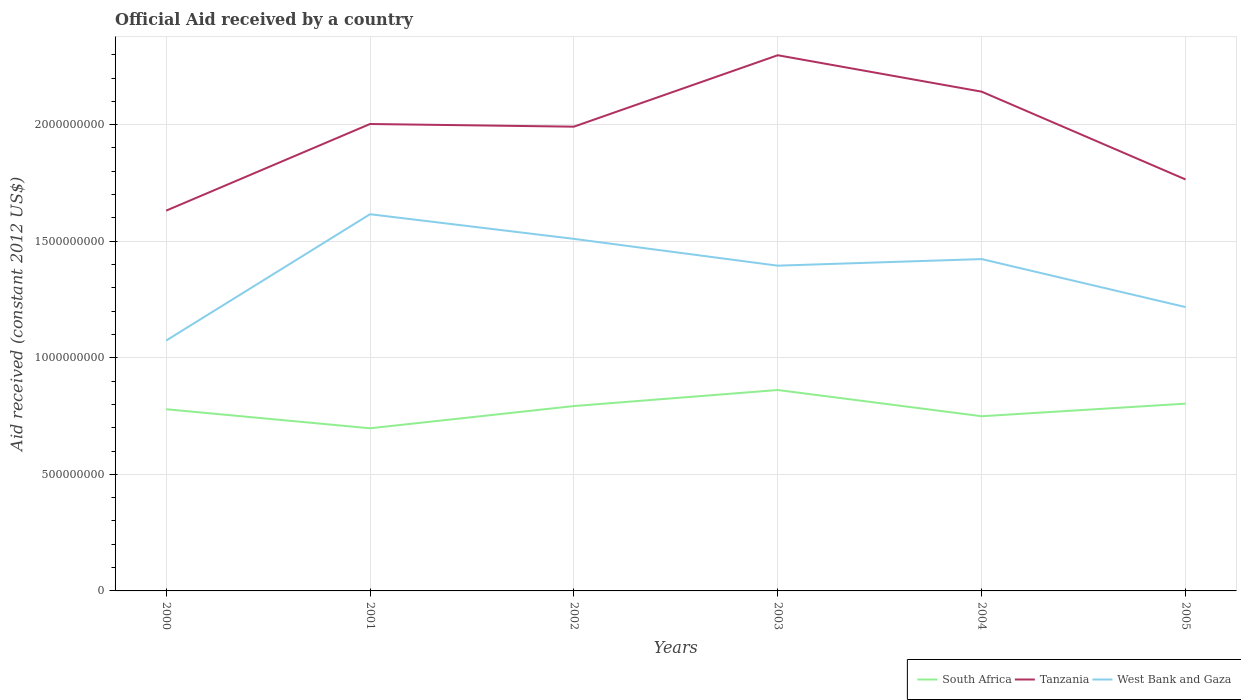How many different coloured lines are there?
Make the answer very short. 3. Does the line corresponding to West Bank and Gaza intersect with the line corresponding to South Africa?
Keep it short and to the point. No. Across all years, what is the maximum net official aid received in South Africa?
Provide a short and direct response. 6.98e+08. What is the total net official aid received in South Africa in the graph?
Ensure brevity in your answer.  -6.88e+07. What is the difference between the highest and the second highest net official aid received in West Bank and Gaza?
Your answer should be compact. 5.42e+08. Is the net official aid received in South Africa strictly greater than the net official aid received in West Bank and Gaza over the years?
Your answer should be compact. Yes. What is the difference between two consecutive major ticks on the Y-axis?
Provide a short and direct response. 5.00e+08. Are the values on the major ticks of Y-axis written in scientific E-notation?
Give a very brief answer. No. How many legend labels are there?
Provide a short and direct response. 3. How are the legend labels stacked?
Ensure brevity in your answer.  Horizontal. What is the title of the graph?
Provide a succinct answer. Official Aid received by a country. What is the label or title of the Y-axis?
Give a very brief answer. Aid received (constant 2012 US$). What is the Aid received (constant 2012 US$) of South Africa in 2000?
Your response must be concise. 7.79e+08. What is the Aid received (constant 2012 US$) in Tanzania in 2000?
Provide a short and direct response. 1.63e+09. What is the Aid received (constant 2012 US$) in West Bank and Gaza in 2000?
Provide a short and direct response. 1.07e+09. What is the Aid received (constant 2012 US$) in South Africa in 2001?
Your answer should be very brief. 6.98e+08. What is the Aid received (constant 2012 US$) in Tanzania in 2001?
Your answer should be compact. 2.00e+09. What is the Aid received (constant 2012 US$) in West Bank and Gaza in 2001?
Provide a succinct answer. 1.62e+09. What is the Aid received (constant 2012 US$) of South Africa in 2002?
Ensure brevity in your answer.  7.93e+08. What is the Aid received (constant 2012 US$) of Tanzania in 2002?
Give a very brief answer. 1.99e+09. What is the Aid received (constant 2012 US$) of West Bank and Gaza in 2002?
Your answer should be compact. 1.51e+09. What is the Aid received (constant 2012 US$) of South Africa in 2003?
Keep it short and to the point. 8.62e+08. What is the Aid received (constant 2012 US$) in Tanzania in 2003?
Your answer should be compact. 2.30e+09. What is the Aid received (constant 2012 US$) of West Bank and Gaza in 2003?
Provide a succinct answer. 1.40e+09. What is the Aid received (constant 2012 US$) of South Africa in 2004?
Make the answer very short. 7.49e+08. What is the Aid received (constant 2012 US$) of Tanzania in 2004?
Offer a terse response. 2.14e+09. What is the Aid received (constant 2012 US$) in West Bank and Gaza in 2004?
Offer a terse response. 1.42e+09. What is the Aid received (constant 2012 US$) in South Africa in 2005?
Your answer should be compact. 8.03e+08. What is the Aid received (constant 2012 US$) of Tanzania in 2005?
Ensure brevity in your answer.  1.77e+09. What is the Aid received (constant 2012 US$) of West Bank and Gaza in 2005?
Your answer should be compact. 1.22e+09. Across all years, what is the maximum Aid received (constant 2012 US$) of South Africa?
Offer a terse response. 8.62e+08. Across all years, what is the maximum Aid received (constant 2012 US$) of Tanzania?
Give a very brief answer. 2.30e+09. Across all years, what is the maximum Aid received (constant 2012 US$) of West Bank and Gaza?
Your response must be concise. 1.62e+09. Across all years, what is the minimum Aid received (constant 2012 US$) in South Africa?
Offer a very short reply. 6.98e+08. Across all years, what is the minimum Aid received (constant 2012 US$) in Tanzania?
Offer a very short reply. 1.63e+09. Across all years, what is the minimum Aid received (constant 2012 US$) of West Bank and Gaza?
Your answer should be compact. 1.07e+09. What is the total Aid received (constant 2012 US$) of South Africa in the graph?
Offer a terse response. 4.68e+09. What is the total Aid received (constant 2012 US$) of Tanzania in the graph?
Provide a succinct answer. 1.18e+1. What is the total Aid received (constant 2012 US$) in West Bank and Gaza in the graph?
Make the answer very short. 8.24e+09. What is the difference between the Aid received (constant 2012 US$) in South Africa in 2000 and that in 2001?
Offer a terse response. 8.16e+07. What is the difference between the Aid received (constant 2012 US$) in Tanzania in 2000 and that in 2001?
Offer a very short reply. -3.72e+08. What is the difference between the Aid received (constant 2012 US$) of West Bank and Gaza in 2000 and that in 2001?
Give a very brief answer. -5.42e+08. What is the difference between the Aid received (constant 2012 US$) in South Africa in 2000 and that in 2002?
Offer a very short reply. -1.37e+07. What is the difference between the Aid received (constant 2012 US$) of Tanzania in 2000 and that in 2002?
Offer a terse response. -3.60e+08. What is the difference between the Aid received (constant 2012 US$) in West Bank and Gaza in 2000 and that in 2002?
Offer a very short reply. -4.36e+08. What is the difference between the Aid received (constant 2012 US$) in South Africa in 2000 and that in 2003?
Keep it short and to the point. -8.25e+07. What is the difference between the Aid received (constant 2012 US$) of Tanzania in 2000 and that in 2003?
Make the answer very short. -6.67e+08. What is the difference between the Aid received (constant 2012 US$) in West Bank and Gaza in 2000 and that in 2003?
Your answer should be very brief. -3.21e+08. What is the difference between the Aid received (constant 2012 US$) of South Africa in 2000 and that in 2004?
Your answer should be compact. 3.00e+07. What is the difference between the Aid received (constant 2012 US$) of Tanzania in 2000 and that in 2004?
Offer a terse response. -5.10e+08. What is the difference between the Aid received (constant 2012 US$) of West Bank and Gaza in 2000 and that in 2004?
Offer a very short reply. -3.50e+08. What is the difference between the Aid received (constant 2012 US$) in South Africa in 2000 and that in 2005?
Your answer should be very brief. -2.40e+07. What is the difference between the Aid received (constant 2012 US$) of Tanzania in 2000 and that in 2005?
Make the answer very short. -1.34e+08. What is the difference between the Aid received (constant 2012 US$) in West Bank and Gaza in 2000 and that in 2005?
Make the answer very short. -1.44e+08. What is the difference between the Aid received (constant 2012 US$) of South Africa in 2001 and that in 2002?
Your answer should be very brief. -9.53e+07. What is the difference between the Aid received (constant 2012 US$) in Tanzania in 2001 and that in 2002?
Your answer should be very brief. 1.14e+07. What is the difference between the Aid received (constant 2012 US$) in West Bank and Gaza in 2001 and that in 2002?
Provide a short and direct response. 1.06e+08. What is the difference between the Aid received (constant 2012 US$) of South Africa in 2001 and that in 2003?
Offer a terse response. -1.64e+08. What is the difference between the Aid received (constant 2012 US$) of Tanzania in 2001 and that in 2003?
Provide a short and direct response. -2.95e+08. What is the difference between the Aid received (constant 2012 US$) of West Bank and Gaza in 2001 and that in 2003?
Provide a succinct answer. 2.21e+08. What is the difference between the Aid received (constant 2012 US$) of South Africa in 2001 and that in 2004?
Ensure brevity in your answer.  -5.17e+07. What is the difference between the Aid received (constant 2012 US$) in Tanzania in 2001 and that in 2004?
Keep it short and to the point. -1.39e+08. What is the difference between the Aid received (constant 2012 US$) in West Bank and Gaza in 2001 and that in 2004?
Offer a terse response. 1.92e+08. What is the difference between the Aid received (constant 2012 US$) of South Africa in 2001 and that in 2005?
Ensure brevity in your answer.  -1.06e+08. What is the difference between the Aid received (constant 2012 US$) in Tanzania in 2001 and that in 2005?
Ensure brevity in your answer.  2.38e+08. What is the difference between the Aid received (constant 2012 US$) in West Bank and Gaza in 2001 and that in 2005?
Provide a succinct answer. 3.98e+08. What is the difference between the Aid received (constant 2012 US$) in South Africa in 2002 and that in 2003?
Offer a terse response. -6.88e+07. What is the difference between the Aid received (constant 2012 US$) in Tanzania in 2002 and that in 2003?
Provide a succinct answer. -3.06e+08. What is the difference between the Aid received (constant 2012 US$) in West Bank and Gaza in 2002 and that in 2003?
Your response must be concise. 1.15e+08. What is the difference between the Aid received (constant 2012 US$) of South Africa in 2002 and that in 2004?
Your answer should be compact. 4.37e+07. What is the difference between the Aid received (constant 2012 US$) of Tanzania in 2002 and that in 2004?
Your answer should be compact. -1.50e+08. What is the difference between the Aid received (constant 2012 US$) in West Bank and Gaza in 2002 and that in 2004?
Ensure brevity in your answer.  8.66e+07. What is the difference between the Aid received (constant 2012 US$) of South Africa in 2002 and that in 2005?
Your answer should be compact. -1.03e+07. What is the difference between the Aid received (constant 2012 US$) of Tanzania in 2002 and that in 2005?
Your response must be concise. 2.26e+08. What is the difference between the Aid received (constant 2012 US$) in West Bank and Gaza in 2002 and that in 2005?
Keep it short and to the point. 2.93e+08. What is the difference between the Aid received (constant 2012 US$) of South Africa in 2003 and that in 2004?
Offer a very short reply. 1.12e+08. What is the difference between the Aid received (constant 2012 US$) of Tanzania in 2003 and that in 2004?
Offer a very short reply. 1.56e+08. What is the difference between the Aid received (constant 2012 US$) of West Bank and Gaza in 2003 and that in 2004?
Your answer should be compact. -2.83e+07. What is the difference between the Aid received (constant 2012 US$) in South Africa in 2003 and that in 2005?
Provide a succinct answer. 5.85e+07. What is the difference between the Aid received (constant 2012 US$) in Tanzania in 2003 and that in 2005?
Keep it short and to the point. 5.33e+08. What is the difference between the Aid received (constant 2012 US$) of West Bank and Gaza in 2003 and that in 2005?
Your answer should be very brief. 1.78e+08. What is the difference between the Aid received (constant 2012 US$) of South Africa in 2004 and that in 2005?
Ensure brevity in your answer.  -5.40e+07. What is the difference between the Aid received (constant 2012 US$) in Tanzania in 2004 and that in 2005?
Offer a terse response. 3.77e+08. What is the difference between the Aid received (constant 2012 US$) of West Bank and Gaza in 2004 and that in 2005?
Provide a succinct answer. 2.06e+08. What is the difference between the Aid received (constant 2012 US$) in South Africa in 2000 and the Aid received (constant 2012 US$) in Tanzania in 2001?
Your answer should be very brief. -1.22e+09. What is the difference between the Aid received (constant 2012 US$) of South Africa in 2000 and the Aid received (constant 2012 US$) of West Bank and Gaza in 2001?
Offer a very short reply. -8.37e+08. What is the difference between the Aid received (constant 2012 US$) of Tanzania in 2000 and the Aid received (constant 2012 US$) of West Bank and Gaza in 2001?
Your answer should be very brief. 1.53e+07. What is the difference between the Aid received (constant 2012 US$) in South Africa in 2000 and the Aid received (constant 2012 US$) in Tanzania in 2002?
Make the answer very short. -1.21e+09. What is the difference between the Aid received (constant 2012 US$) of South Africa in 2000 and the Aid received (constant 2012 US$) of West Bank and Gaza in 2002?
Give a very brief answer. -7.31e+08. What is the difference between the Aid received (constant 2012 US$) in Tanzania in 2000 and the Aid received (constant 2012 US$) in West Bank and Gaza in 2002?
Offer a very short reply. 1.21e+08. What is the difference between the Aid received (constant 2012 US$) in South Africa in 2000 and the Aid received (constant 2012 US$) in Tanzania in 2003?
Keep it short and to the point. -1.52e+09. What is the difference between the Aid received (constant 2012 US$) of South Africa in 2000 and the Aid received (constant 2012 US$) of West Bank and Gaza in 2003?
Your answer should be very brief. -6.16e+08. What is the difference between the Aid received (constant 2012 US$) of Tanzania in 2000 and the Aid received (constant 2012 US$) of West Bank and Gaza in 2003?
Your answer should be compact. 2.36e+08. What is the difference between the Aid received (constant 2012 US$) of South Africa in 2000 and the Aid received (constant 2012 US$) of Tanzania in 2004?
Give a very brief answer. -1.36e+09. What is the difference between the Aid received (constant 2012 US$) in South Africa in 2000 and the Aid received (constant 2012 US$) in West Bank and Gaza in 2004?
Ensure brevity in your answer.  -6.44e+08. What is the difference between the Aid received (constant 2012 US$) in Tanzania in 2000 and the Aid received (constant 2012 US$) in West Bank and Gaza in 2004?
Give a very brief answer. 2.08e+08. What is the difference between the Aid received (constant 2012 US$) of South Africa in 2000 and the Aid received (constant 2012 US$) of Tanzania in 2005?
Offer a very short reply. -9.86e+08. What is the difference between the Aid received (constant 2012 US$) of South Africa in 2000 and the Aid received (constant 2012 US$) of West Bank and Gaza in 2005?
Provide a succinct answer. -4.38e+08. What is the difference between the Aid received (constant 2012 US$) of Tanzania in 2000 and the Aid received (constant 2012 US$) of West Bank and Gaza in 2005?
Provide a short and direct response. 4.14e+08. What is the difference between the Aid received (constant 2012 US$) in South Africa in 2001 and the Aid received (constant 2012 US$) in Tanzania in 2002?
Ensure brevity in your answer.  -1.29e+09. What is the difference between the Aid received (constant 2012 US$) in South Africa in 2001 and the Aid received (constant 2012 US$) in West Bank and Gaza in 2002?
Make the answer very short. -8.12e+08. What is the difference between the Aid received (constant 2012 US$) in Tanzania in 2001 and the Aid received (constant 2012 US$) in West Bank and Gaza in 2002?
Your answer should be compact. 4.93e+08. What is the difference between the Aid received (constant 2012 US$) of South Africa in 2001 and the Aid received (constant 2012 US$) of Tanzania in 2003?
Provide a succinct answer. -1.60e+09. What is the difference between the Aid received (constant 2012 US$) of South Africa in 2001 and the Aid received (constant 2012 US$) of West Bank and Gaza in 2003?
Give a very brief answer. -6.97e+08. What is the difference between the Aid received (constant 2012 US$) in Tanzania in 2001 and the Aid received (constant 2012 US$) in West Bank and Gaza in 2003?
Your answer should be very brief. 6.08e+08. What is the difference between the Aid received (constant 2012 US$) of South Africa in 2001 and the Aid received (constant 2012 US$) of Tanzania in 2004?
Offer a very short reply. -1.44e+09. What is the difference between the Aid received (constant 2012 US$) of South Africa in 2001 and the Aid received (constant 2012 US$) of West Bank and Gaza in 2004?
Offer a terse response. -7.26e+08. What is the difference between the Aid received (constant 2012 US$) of Tanzania in 2001 and the Aid received (constant 2012 US$) of West Bank and Gaza in 2004?
Offer a very short reply. 5.79e+08. What is the difference between the Aid received (constant 2012 US$) in South Africa in 2001 and the Aid received (constant 2012 US$) in Tanzania in 2005?
Your answer should be compact. -1.07e+09. What is the difference between the Aid received (constant 2012 US$) in South Africa in 2001 and the Aid received (constant 2012 US$) in West Bank and Gaza in 2005?
Ensure brevity in your answer.  -5.20e+08. What is the difference between the Aid received (constant 2012 US$) of Tanzania in 2001 and the Aid received (constant 2012 US$) of West Bank and Gaza in 2005?
Keep it short and to the point. 7.85e+08. What is the difference between the Aid received (constant 2012 US$) of South Africa in 2002 and the Aid received (constant 2012 US$) of Tanzania in 2003?
Offer a very short reply. -1.50e+09. What is the difference between the Aid received (constant 2012 US$) in South Africa in 2002 and the Aid received (constant 2012 US$) in West Bank and Gaza in 2003?
Your answer should be compact. -6.02e+08. What is the difference between the Aid received (constant 2012 US$) of Tanzania in 2002 and the Aid received (constant 2012 US$) of West Bank and Gaza in 2003?
Provide a succinct answer. 5.96e+08. What is the difference between the Aid received (constant 2012 US$) in South Africa in 2002 and the Aid received (constant 2012 US$) in Tanzania in 2004?
Provide a short and direct response. -1.35e+09. What is the difference between the Aid received (constant 2012 US$) in South Africa in 2002 and the Aid received (constant 2012 US$) in West Bank and Gaza in 2004?
Provide a short and direct response. -6.30e+08. What is the difference between the Aid received (constant 2012 US$) in Tanzania in 2002 and the Aid received (constant 2012 US$) in West Bank and Gaza in 2004?
Give a very brief answer. 5.68e+08. What is the difference between the Aid received (constant 2012 US$) in South Africa in 2002 and the Aid received (constant 2012 US$) in Tanzania in 2005?
Make the answer very short. -9.72e+08. What is the difference between the Aid received (constant 2012 US$) of South Africa in 2002 and the Aid received (constant 2012 US$) of West Bank and Gaza in 2005?
Your answer should be compact. -4.25e+08. What is the difference between the Aid received (constant 2012 US$) of Tanzania in 2002 and the Aid received (constant 2012 US$) of West Bank and Gaza in 2005?
Your answer should be very brief. 7.74e+08. What is the difference between the Aid received (constant 2012 US$) of South Africa in 2003 and the Aid received (constant 2012 US$) of Tanzania in 2004?
Offer a very short reply. -1.28e+09. What is the difference between the Aid received (constant 2012 US$) of South Africa in 2003 and the Aid received (constant 2012 US$) of West Bank and Gaza in 2004?
Give a very brief answer. -5.62e+08. What is the difference between the Aid received (constant 2012 US$) of Tanzania in 2003 and the Aid received (constant 2012 US$) of West Bank and Gaza in 2004?
Your response must be concise. 8.74e+08. What is the difference between the Aid received (constant 2012 US$) in South Africa in 2003 and the Aid received (constant 2012 US$) in Tanzania in 2005?
Keep it short and to the point. -9.03e+08. What is the difference between the Aid received (constant 2012 US$) in South Africa in 2003 and the Aid received (constant 2012 US$) in West Bank and Gaza in 2005?
Your response must be concise. -3.56e+08. What is the difference between the Aid received (constant 2012 US$) of Tanzania in 2003 and the Aid received (constant 2012 US$) of West Bank and Gaza in 2005?
Your answer should be very brief. 1.08e+09. What is the difference between the Aid received (constant 2012 US$) in South Africa in 2004 and the Aid received (constant 2012 US$) in Tanzania in 2005?
Your answer should be compact. -1.02e+09. What is the difference between the Aid received (constant 2012 US$) in South Africa in 2004 and the Aid received (constant 2012 US$) in West Bank and Gaza in 2005?
Your response must be concise. -4.68e+08. What is the difference between the Aid received (constant 2012 US$) of Tanzania in 2004 and the Aid received (constant 2012 US$) of West Bank and Gaza in 2005?
Your answer should be compact. 9.24e+08. What is the average Aid received (constant 2012 US$) of South Africa per year?
Your response must be concise. 7.81e+08. What is the average Aid received (constant 2012 US$) in Tanzania per year?
Provide a short and direct response. 1.97e+09. What is the average Aid received (constant 2012 US$) of West Bank and Gaza per year?
Offer a terse response. 1.37e+09. In the year 2000, what is the difference between the Aid received (constant 2012 US$) in South Africa and Aid received (constant 2012 US$) in Tanzania?
Ensure brevity in your answer.  -8.52e+08. In the year 2000, what is the difference between the Aid received (constant 2012 US$) of South Africa and Aid received (constant 2012 US$) of West Bank and Gaza?
Ensure brevity in your answer.  -2.95e+08. In the year 2000, what is the difference between the Aid received (constant 2012 US$) in Tanzania and Aid received (constant 2012 US$) in West Bank and Gaza?
Make the answer very short. 5.57e+08. In the year 2001, what is the difference between the Aid received (constant 2012 US$) in South Africa and Aid received (constant 2012 US$) in Tanzania?
Offer a terse response. -1.31e+09. In the year 2001, what is the difference between the Aid received (constant 2012 US$) of South Africa and Aid received (constant 2012 US$) of West Bank and Gaza?
Ensure brevity in your answer.  -9.18e+08. In the year 2001, what is the difference between the Aid received (constant 2012 US$) in Tanzania and Aid received (constant 2012 US$) in West Bank and Gaza?
Keep it short and to the point. 3.87e+08. In the year 2002, what is the difference between the Aid received (constant 2012 US$) in South Africa and Aid received (constant 2012 US$) in Tanzania?
Your answer should be compact. -1.20e+09. In the year 2002, what is the difference between the Aid received (constant 2012 US$) in South Africa and Aid received (constant 2012 US$) in West Bank and Gaza?
Provide a short and direct response. -7.17e+08. In the year 2002, what is the difference between the Aid received (constant 2012 US$) in Tanzania and Aid received (constant 2012 US$) in West Bank and Gaza?
Offer a terse response. 4.81e+08. In the year 2003, what is the difference between the Aid received (constant 2012 US$) of South Africa and Aid received (constant 2012 US$) of Tanzania?
Give a very brief answer. -1.44e+09. In the year 2003, what is the difference between the Aid received (constant 2012 US$) of South Africa and Aid received (constant 2012 US$) of West Bank and Gaza?
Provide a short and direct response. -5.33e+08. In the year 2003, what is the difference between the Aid received (constant 2012 US$) of Tanzania and Aid received (constant 2012 US$) of West Bank and Gaza?
Keep it short and to the point. 9.03e+08. In the year 2004, what is the difference between the Aid received (constant 2012 US$) of South Africa and Aid received (constant 2012 US$) of Tanzania?
Offer a very short reply. -1.39e+09. In the year 2004, what is the difference between the Aid received (constant 2012 US$) of South Africa and Aid received (constant 2012 US$) of West Bank and Gaza?
Offer a terse response. -6.74e+08. In the year 2004, what is the difference between the Aid received (constant 2012 US$) in Tanzania and Aid received (constant 2012 US$) in West Bank and Gaza?
Provide a succinct answer. 7.18e+08. In the year 2005, what is the difference between the Aid received (constant 2012 US$) in South Africa and Aid received (constant 2012 US$) in Tanzania?
Your response must be concise. -9.62e+08. In the year 2005, what is the difference between the Aid received (constant 2012 US$) in South Africa and Aid received (constant 2012 US$) in West Bank and Gaza?
Provide a short and direct response. -4.14e+08. In the year 2005, what is the difference between the Aid received (constant 2012 US$) of Tanzania and Aid received (constant 2012 US$) of West Bank and Gaza?
Make the answer very short. 5.48e+08. What is the ratio of the Aid received (constant 2012 US$) in South Africa in 2000 to that in 2001?
Your answer should be compact. 1.12. What is the ratio of the Aid received (constant 2012 US$) in Tanzania in 2000 to that in 2001?
Give a very brief answer. 0.81. What is the ratio of the Aid received (constant 2012 US$) of West Bank and Gaza in 2000 to that in 2001?
Offer a very short reply. 0.66. What is the ratio of the Aid received (constant 2012 US$) of South Africa in 2000 to that in 2002?
Make the answer very short. 0.98. What is the ratio of the Aid received (constant 2012 US$) of Tanzania in 2000 to that in 2002?
Make the answer very short. 0.82. What is the ratio of the Aid received (constant 2012 US$) of West Bank and Gaza in 2000 to that in 2002?
Offer a very short reply. 0.71. What is the ratio of the Aid received (constant 2012 US$) in South Africa in 2000 to that in 2003?
Your response must be concise. 0.9. What is the ratio of the Aid received (constant 2012 US$) of Tanzania in 2000 to that in 2003?
Your response must be concise. 0.71. What is the ratio of the Aid received (constant 2012 US$) of West Bank and Gaza in 2000 to that in 2003?
Your answer should be compact. 0.77. What is the ratio of the Aid received (constant 2012 US$) of South Africa in 2000 to that in 2004?
Keep it short and to the point. 1.04. What is the ratio of the Aid received (constant 2012 US$) in Tanzania in 2000 to that in 2004?
Offer a very short reply. 0.76. What is the ratio of the Aid received (constant 2012 US$) of West Bank and Gaza in 2000 to that in 2004?
Ensure brevity in your answer.  0.75. What is the ratio of the Aid received (constant 2012 US$) of South Africa in 2000 to that in 2005?
Give a very brief answer. 0.97. What is the ratio of the Aid received (constant 2012 US$) in Tanzania in 2000 to that in 2005?
Provide a short and direct response. 0.92. What is the ratio of the Aid received (constant 2012 US$) in West Bank and Gaza in 2000 to that in 2005?
Your answer should be compact. 0.88. What is the ratio of the Aid received (constant 2012 US$) in South Africa in 2001 to that in 2002?
Keep it short and to the point. 0.88. What is the ratio of the Aid received (constant 2012 US$) in West Bank and Gaza in 2001 to that in 2002?
Your response must be concise. 1.07. What is the ratio of the Aid received (constant 2012 US$) of South Africa in 2001 to that in 2003?
Keep it short and to the point. 0.81. What is the ratio of the Aid received (constant 2012 US$) of Tanzania in 2001 to that in 2003?
Make the answer very short. 0.87. What is the ratio of the Aid received (constant 2012 US$) of West Bank and Gaza in 2001 to that in 2003?
Give a very brief answer. 1.16. What is the ratio of the Aid received (constant 2012 US$) of South Africa in 2001 to that in 2004?
Your response must be concise. 0.93. What is the ratio of the Aid received (constant 2012 US$) of Tanzania in 2001 to that in 2004?
Your answer should be very brief. 0.94. What is the ratio of the Aid received (constant 2012 US$) in West Bank and Gaza in 2001 to that in 2004?
Give a very brief answer. 1.14. What is the ratio of the Aid received (constant 2012 US$) of South Africa in 2001 to that in 2005?
Provide a short and direct response. 0.87. What is the ratio of the Aid received (constant 2012 US$) in Tanzania in 2001 to that in 2005?
Provide a succinct answer. 1.13. What is the ratio of the Aid received (constant 2012 US$) of West Bank and Gaza in 2001 to that in 2005?
Ensure brevity in your answer.  1.33. What is the ratio of the Aid received (constant 2012 US$) of South Africa in 2002 to that in 2003?
Your response must be concise. 0.92. What is the ratio of the Aid received (constant 2012 US$) of Tanzania in 2002 to that in 2003?
Keep it short and to the point. 0.87. What is the ratio of the Aid received (constant 2012 US$) in West Bank and Gaza in 2002 to that in 2003?
Provide a short and direct response. 1.08. What is the ratio of the Aid received (constant 2012 US$) in South Africa in 2002 to that in 2004?
Provide a succinct answer. 1.06. What is the ratio of the Aid received (constant 2012 US$) of Tanzania in 2002 to that in 2004?
Offer a very short reply. 0.93. What is the ratio of the Aid received (constant 2012 US$) of West Bank and Gaza in 2002 to that in 2004?
Keep it short and to the point. 1.06. What is the ratio of the Aid received (constant 2012 US$) in South Africa in 2002 to that in 2005?
Your answer should be very brief. 0.99. What is the ratio of the Aid received (constant 2012 US$) of Tanzania in 2002 to that in 2005?
Your response must be concise. 1.13. What is the ratio of the Aid received (constant 2012 US$) of West Bank and Gaza in 2002 to that in 2005?
Your response must be concise. 1.24. What is the ratio of the Aid received (constant 2012 US$) in South Africa in 2003 to that in 2004?
Ensure brevity in your answer.  1.15. What is the ratio of the Aid received (constant 2012 US$) in Tanzania in 2003 to that in 2004?
Keep it short and to the point. 1.07. What is the ratio of the Aid received (constant 2012 US$) of West Bank and Gaza in 2003 to that in 2004?
Provide a succinct answer. 0.98. What is the ratio of the Aid received (constant 2012 US$) in South Africa in 2003 to that in 2005?
Your answer should be very brief. 1.07. What is the ratio of the Aid received (constant 2012 US$) of Tanzania in 2003 to that in 2005?
Offer a very short reply. 1.3. What is the ratio of the Aid received (constant 2012 US$) of West Bank and Gaza in 2003 to that in 2005?
Make the answer very short. 1.15. What is the ratio of the Aid received (constant 2012 US$) in South Africa in 2004 to that in 2005?
Provide a short and direct response. 0.93. What is the ratio of the Aid received (constant 2012 US$) in Tanzania in 2004 to that in 2005?
Give a very brief answer. 1.21. What is the ratio of the Aid received (constant 2012 US$) of West Bank and Gaza in 2004 to that in 2005?
Give a very brief answer. 1.17. What is the difference between the highest and the second highest Aid received (constant 2012 US$) in South Africa?
Provide a succinct answer. 5.85e+07. What is the difference between the highest and the second highest Aid received (constant 2012 US$) in Tanzania?
Offer a very short reply. 1.56e+08. What is the difference between the highest and the second highest Aid received (constant 2012 US$) of West Bank and Gaza?
Provide a succinct answer. 1.06e+08. What is the difference between the highest and the lowest Aid received (constant 2012 US$) in South Africa?
Offer a terse response. 1.64e+08. What is the difference between the highest and the lowest Aid received (constant 2012 US$) of Tanzania?
Provide a succinct answer. 6.67e+08. What is the difference between the highest and the lowest Aid received (constant 2012 US$) of West Bank and Gaza?
Offer a terse response. 5.42e+08. 